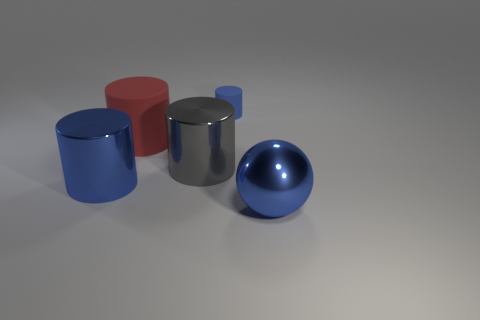How many small objects are green metallic balls or red cylinders? In the image presented, there are no small objects that are green metallic balls, and there is one object that could be considered a red cylinder. Therefore, the answer is one. 